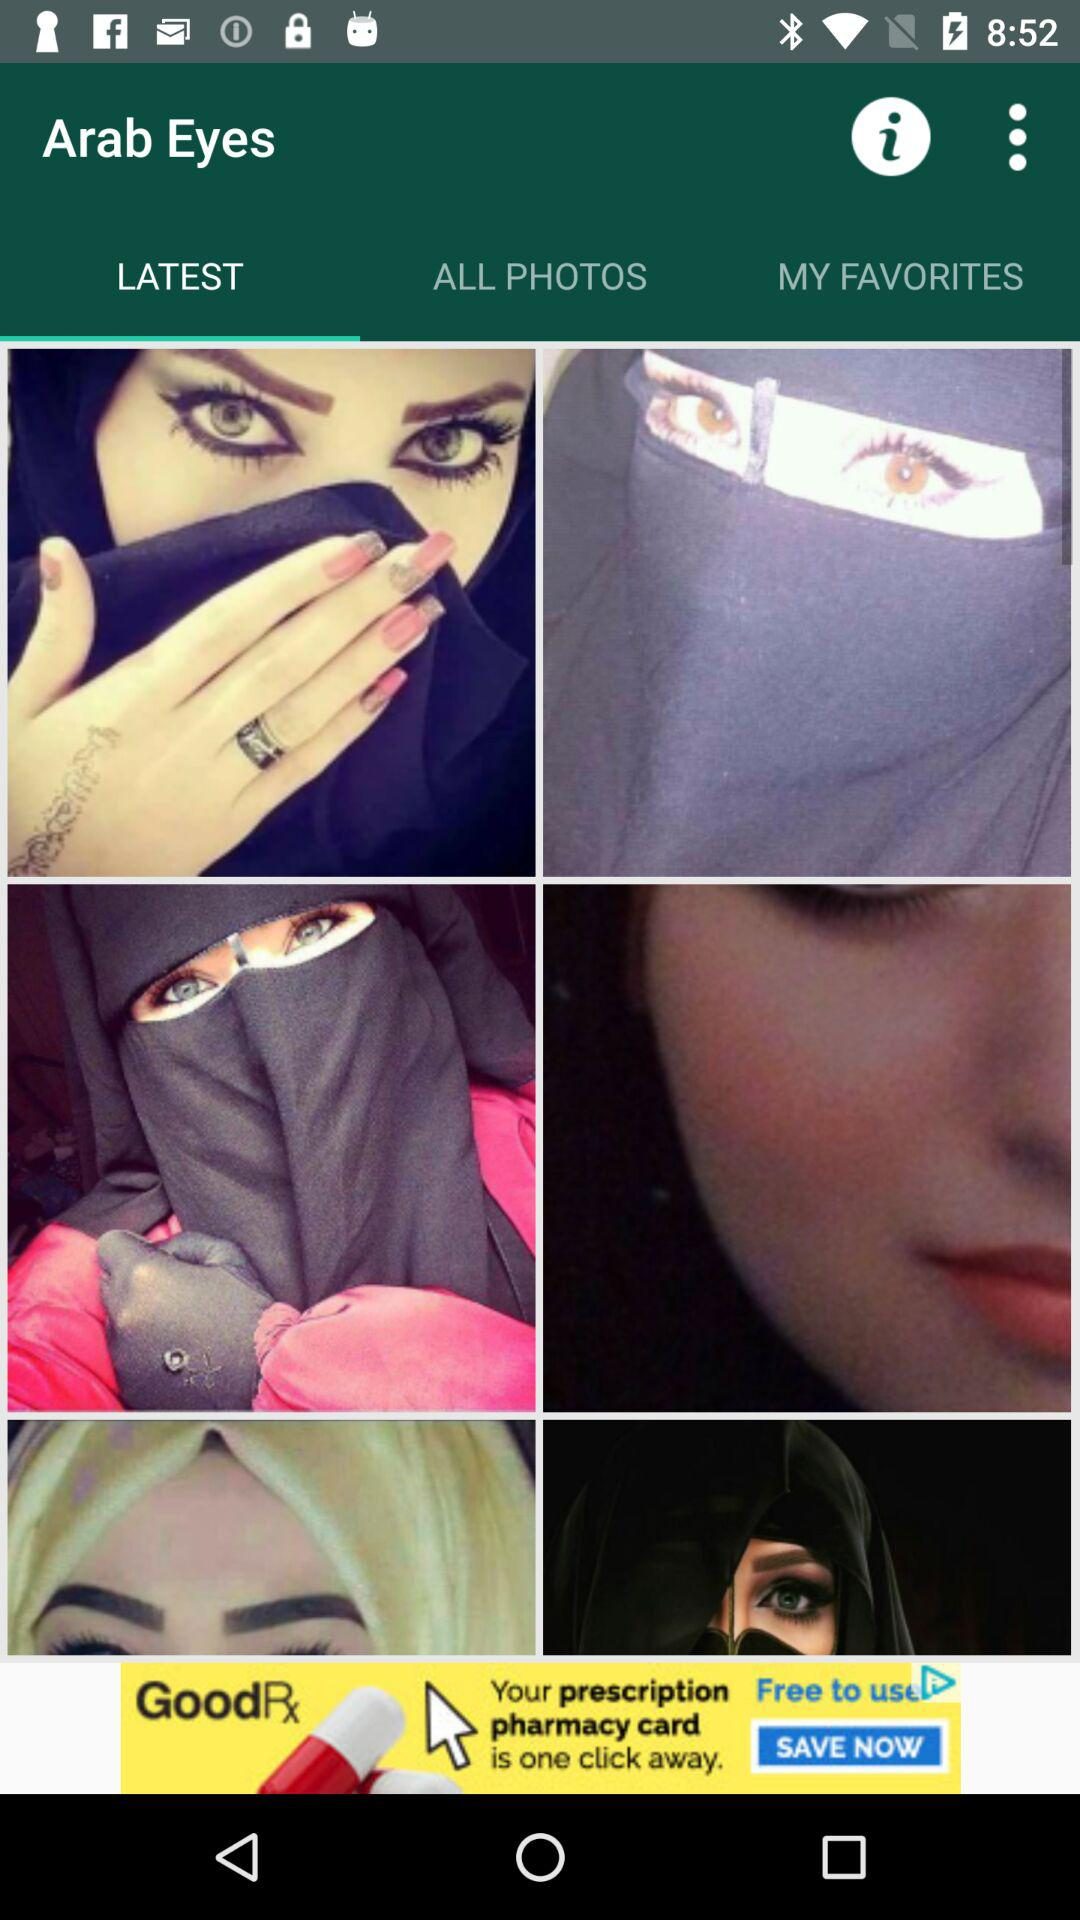Which tab is selected? The selected tab is "LATEST". 